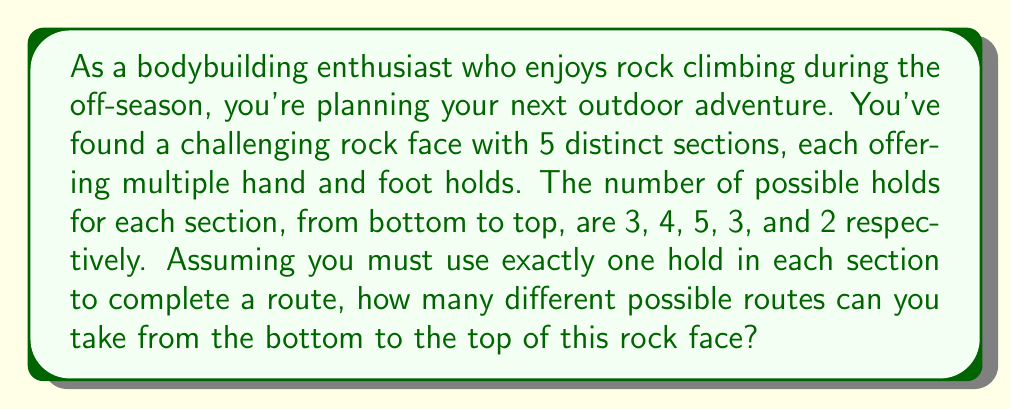Provide a solution to this math problem. To solve this problem, we'll use the multiplication principle of counting. This principle states that if we have a sequence of independent choices, where the number of options for each choice is known, the total number of possible outcomes is the product of the number of options for each choice.

In this case:
1. We have 5 distinct sections (choices) to make.
2. For each section, we must choose exactly one hold.
3. The number of holds available in each section is independent of the choices made in other sections.

Let's break it down step-by-step:

1. First section (bottom): 3 possible holds
2. Second section: 4 possible holds
3. Third section: 5 possible holds
4. Fourth section: 3 possible holds
5. Fifth section (top): 2 possible holds

To find the total number of possible routes, we multiply these numbers together:

$$\text{Total routes} = 3 \times 4 \times 5 \times 3 \times 2$$

Calculating this:
$$\text{Total routes} = 360$$

Therefore, there are 360 different possible routes from the bottom to the top of this rock face.
Answer: $360$ possible routes 